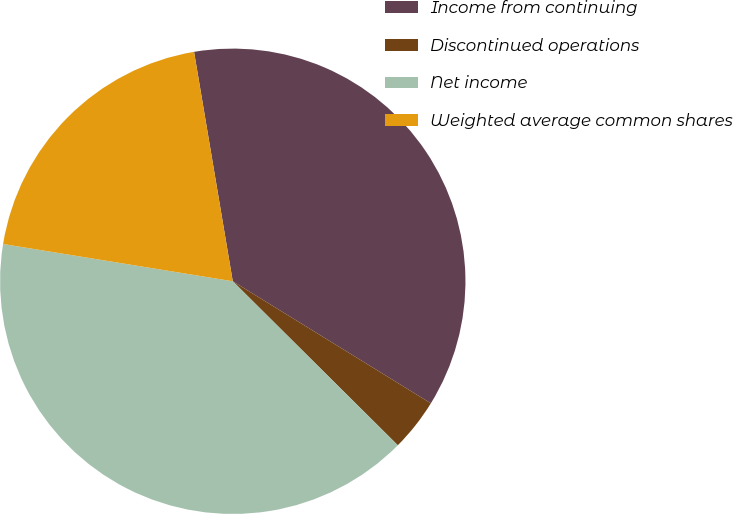<chart> <loc_0><loc_0><loc_500><loc_500><pie_chart><fcel>Income from continuing<fcel>Discontinued operations<fcel>Net income<fcel>Weighted average common shares<nl><fcel>36.45%<fcel>3.66%<fcel>40.11%<fcel>19.78%<nl></chart> 